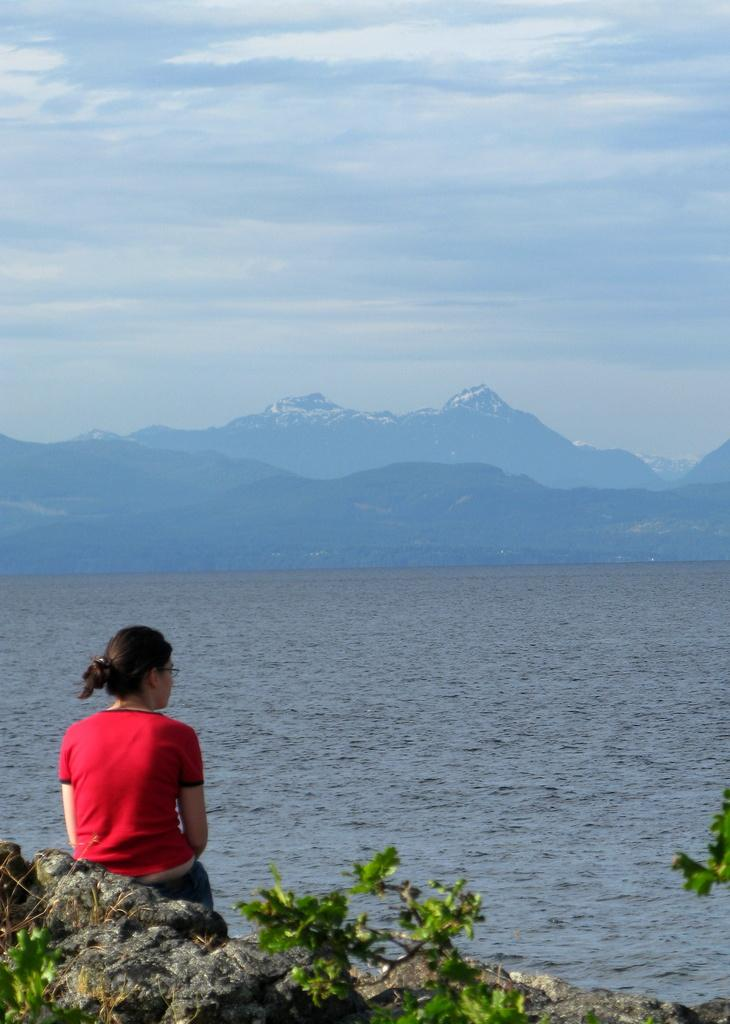What is the weather like in the image? The sky in the image is cloudy. What type of landscape can be seen in the image? There are mountains and a sea visible in the image. What is the lady in the image doing? The lady is sitting on a rock in the image. What type of vegetation is present in the image? There is a tree at the bottom of the image. How many fish can be seen swimming in the shelf in the image? There is no shelf or fish present in the image. What type of country is depicted in the image? The image does not depict a specific country; it features such as mountains, a sea, and a tree are present, but no country is identifiable. 